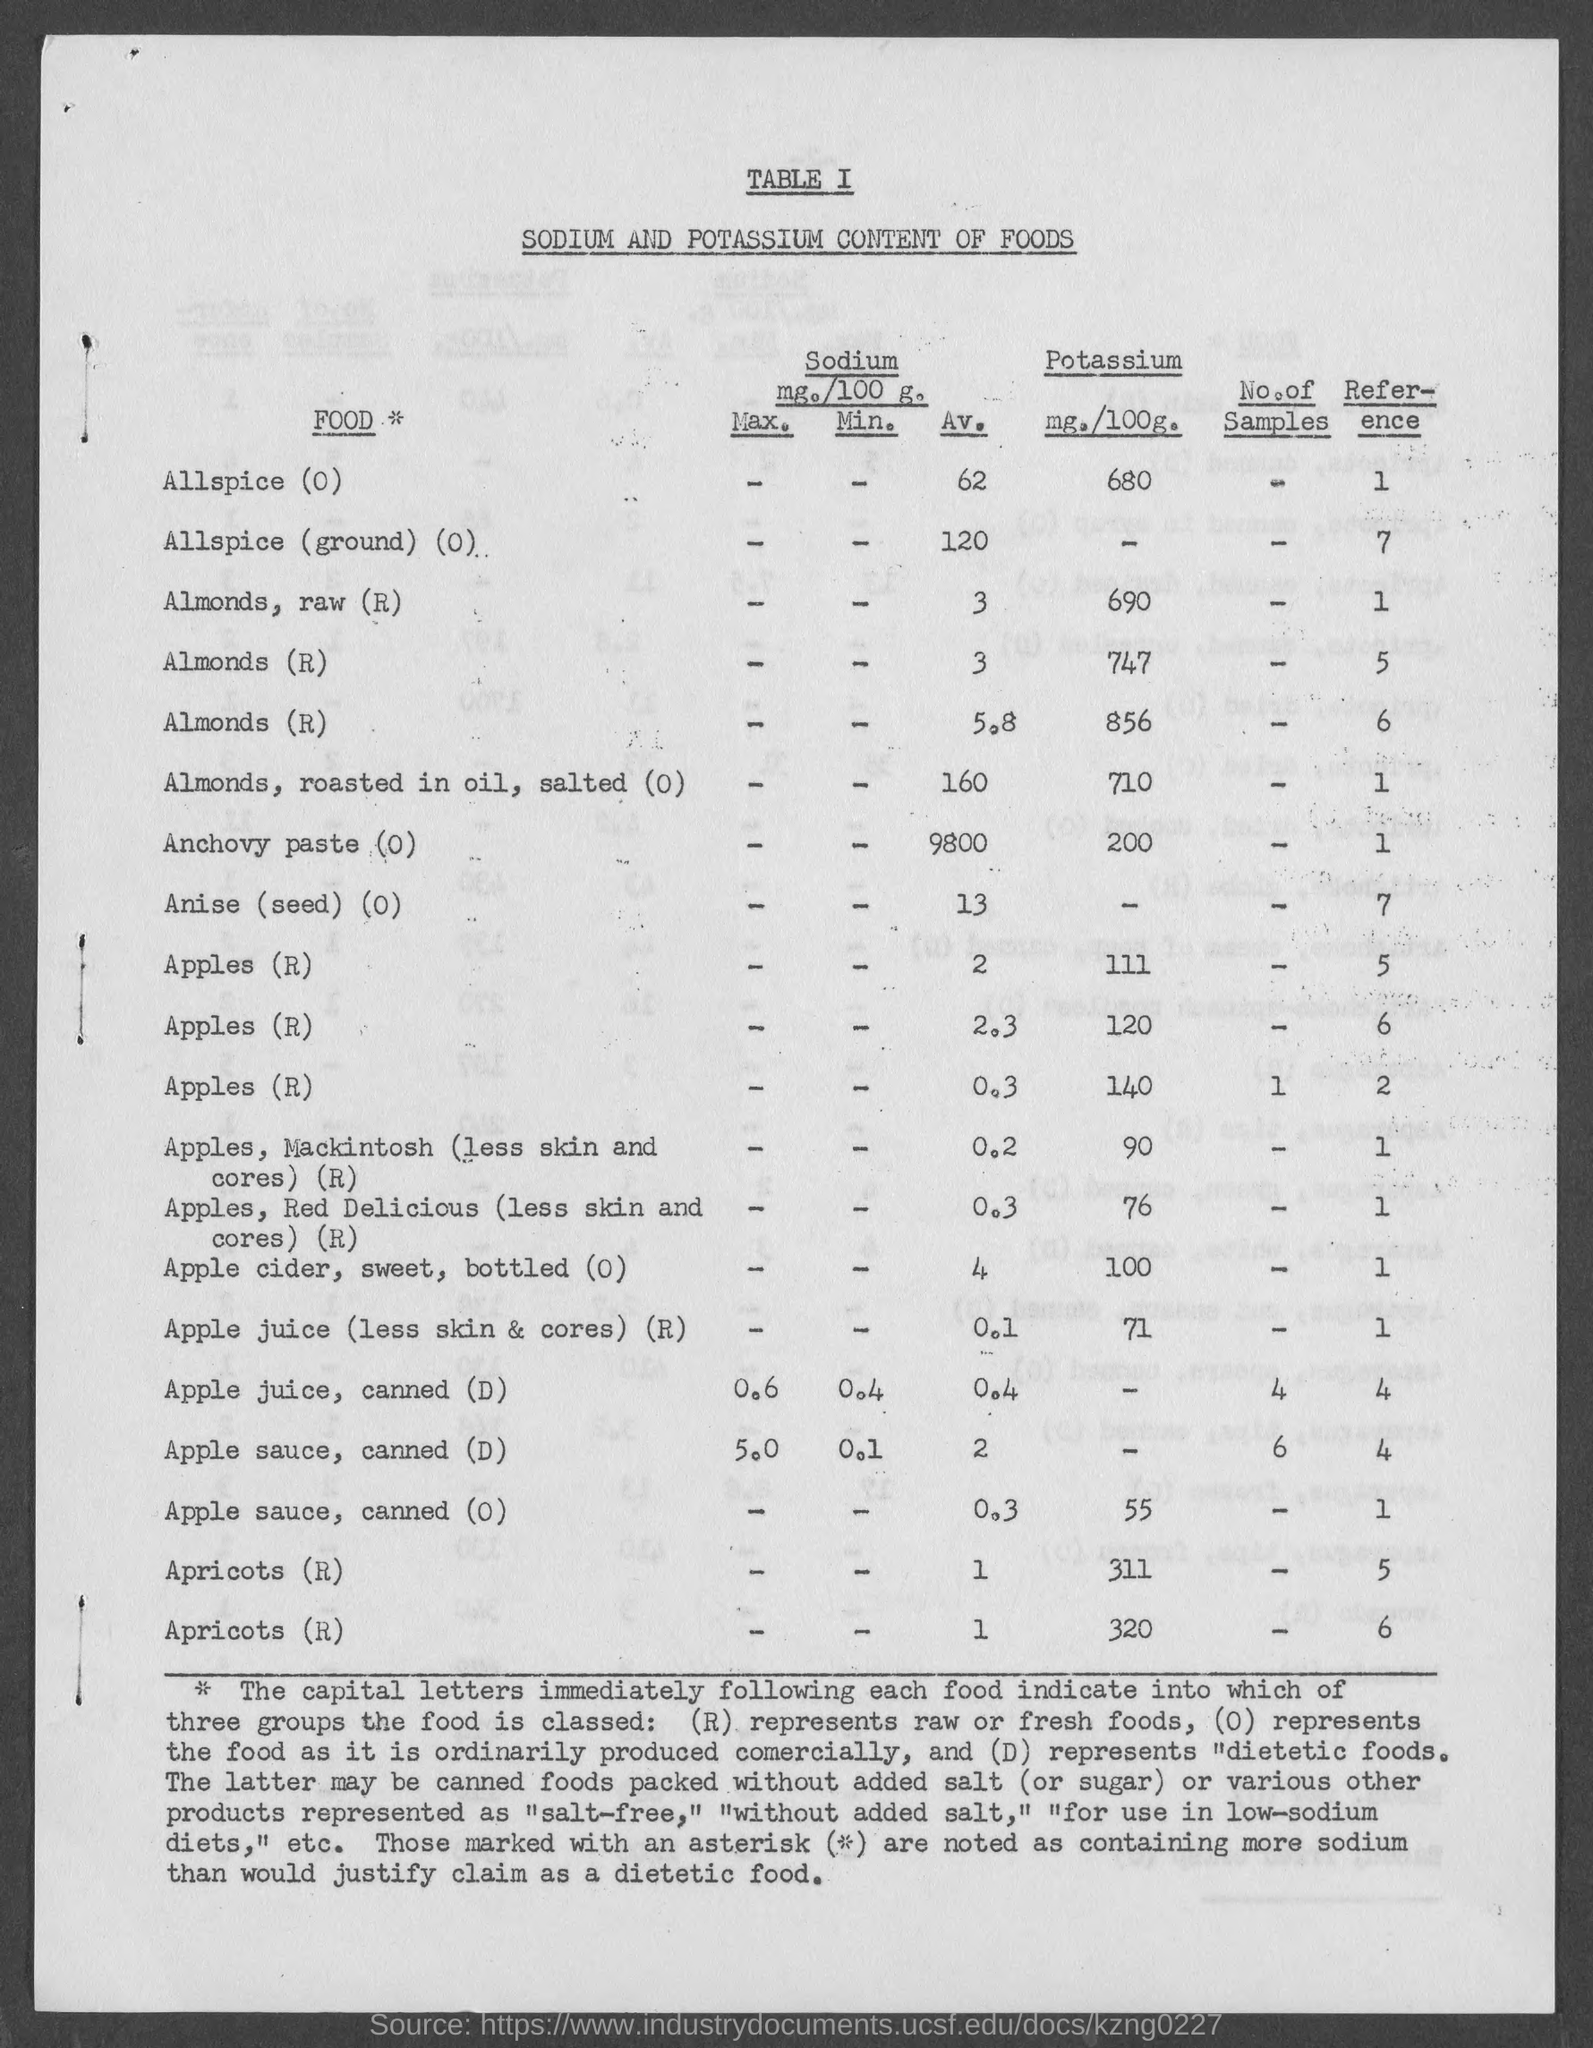Point out several critical features in this image. The average sodium content in almonds, raw, is 3 milligrams per serving. The amount of Potassium in Anchovy Paste is 0. The average sodium content in a bottle of apple cider, sweet, bottled(0) is 4. The average sodium content in anise (seed) is not present. The range of sodium levels is from 13 to 0 milligrams per 100 grams. The serving of roasted almonds in oil, salted with no potassium content is 710 calories. 